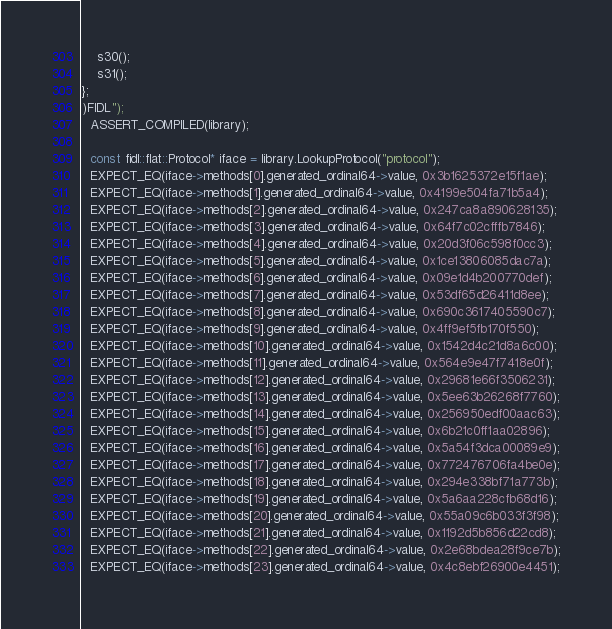<code> <loc_0><loc_0><loc_500><loc_500><_C++_>    s30();
    s31();
};
)FIDL");
  ASSERT_COMPILED(library);

  const fidl::flat::Protocol* iface = library.LookupProtocol("protocol");
  EXPECT_EQ(iface->methods[0].generated_ordinal64->value, 0x3b1625372e15f1ae);
  EXPECT_EQ(iface->methods[1].generated_ordinal64->value, 0x4199e504fa71b5a4);
  EXPECT_EQ(iface->methods[2].generated_ordinal64->value, 0x247ca8a890628135);
  EXPECT_EQ(iface->methods[3].generated_ordinal64->value, 0x64f7c02cfffb7846);
  EXPECT_EQ(iface->methods[4].generated_ordinal64->value, 0x20d3f06c598f0cc3);
  EXPECT_EQ(iface->methods[5].generated_ordinal64->value, 0x1ce13806085dac7a);
  EXPECT_EQ(iface->methods[6].generated_ordinal64->value, 0x09e1d4b200770def);
  EXPECT_EQ(iface->methods[7].generated_ordinal64->value, 0x53df65d26411d8ee);
  EXPECT_EQ(iface->methods[8].generated_ordinal64->value, 0x690c3617405590c7);
  EXPECT_EQ(iface->methods[9].generated_ordinal64->value, 0x4ff9ef5fb170f550);
  EXPECT_EQ(iface->methods[10].generated_ordinal64->value, 0x1542d4c21d8a6c00);
  EXPECT_EQ(iface->methods[11].generated_ordinal64->value, 0x564e9e47f7418e0f);
  EXPECT_EQ(iface->methods[12].generated_ordinal64->value, 0x29681e66f3506231);
  EXPECT_EQ(iface->methods[13].generated_ordinal64->value, 0x5ee63b26268f7760);
  EXPECT_EQ(iface->methods[14].generated_ordinal64->value, 0x256950edf00aac63);
  EXPECT_EQ(iface->methods[15].generated_ordinal64->value, 0x6b21c0ff1aa02896);
  EXPECT_EQ(iface->methods[16].generated_ordinal64->value, 0x5a54f3dca00089e9);
  EXPECT_EQ(iface->methods[17].generated_ordinal64->value, 0x772476706fa4be0e);
  EXPECT_EQ(iface->methods[18].generated_ordinal64->value, 0x294e338bf71a773b);
  EXPECT_EQ(iface->methods[19].generated_ordinal64->value, 0x5a6aa228cfb68d16);
  EXPECT_EQ(iface->methods[20].generated_ordinal64->value, 0x55a09c6b033f3f98);
  EXPECT_EQ(iface->methods[21].generated_ordinal64->value, 0x1192d5b856d22cd8);
  EXPECT_EQ(iface->methods[22].generated_ordinal64->value, 0x2e68bdea28f9ce7b);
  EXPECT_EQ(iface->methods[23].generated_ordinal64->value, 0x4c8ebf26900e4451);</code> 